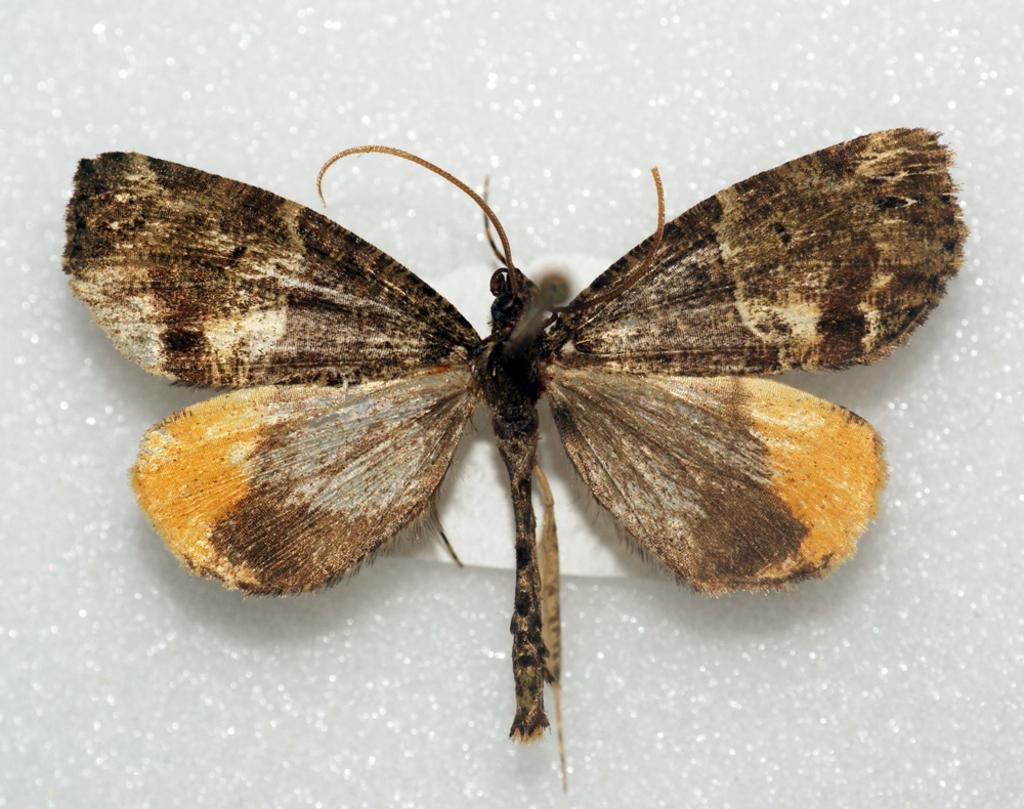What type of creature is present in the image? There is an insect in the image. What is the insect resting on in the image? The insect is on a white surface. How many babies are visible in the image? There are no babies present in the image; it features an insect on a white surface. What type of vegetable is being used as a desk for the secretary in the image? There is no secretary or celery present in the image. 